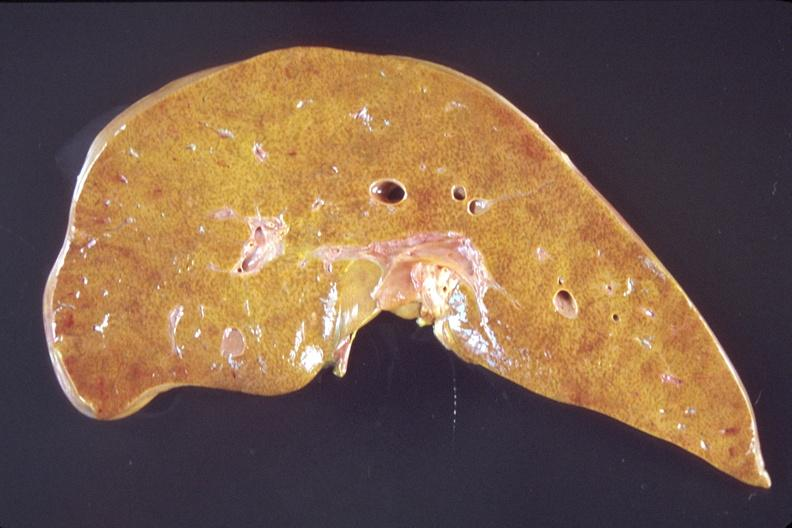s hepatobiliary present?
Answer the question using a single word or phrase. Yes 